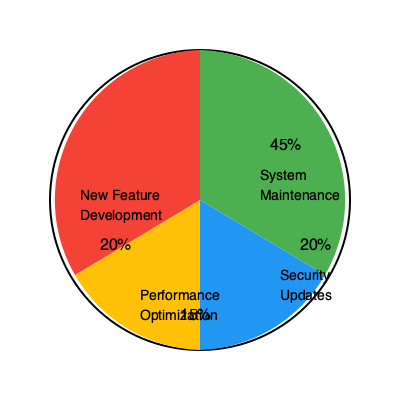As a senior executive prioritizing system stability, you're presented with the above pie chart showing the current resource allocation for your software development team. Given that the team has recently experienced an increase in system downtime, what percentage of resources should be reallocated from new feature development to system maintenance to address this issue while maintaining a balanced approach? To address this question, we need to follow these steps:

1. Analyze the current resource allocation:
   - System Maintenance: 45%
   - Security Updates: 20%
   - Performance Optimization: 15%
   - New Feature Development: 20%

2. Identify the areas related to system stability:
   - System Maintenance directly impacts stability
   - Security Updates indirectly contribute to stability
   - Performance Optimization can affect stability

3. Consider the current allocation for stability-related tasks:
   45% + 20% + 15% = 80% of resources are already allocated to stability-related tasks

4. Evaluate the need for reallocation:
   - With recent increases in downtime, more resources should be allocated to System Maintenance
   - New Feature Development is the only area that can be reduced without compromising other critical aspects

5. Determine an appropriate reallocation:
   - A 5% increase in System Maintenance would be significant without drastically affecting new development
   - This would bring System Maintenance to 50% and reduce New Feature Development to 15%

6. Consider the impact:
   - This reallocation maintains a balanced approach by still allocating resources to new development
   - It addresses the stability issues by increasing focus on system maintenance
   - The total resources allocated to stability-related tasks would increase to 85%

7. Calculate the percentage to be reallocated:
   5% should be reallocated from New Feature Development to System Maintenance
Answer: 5% 